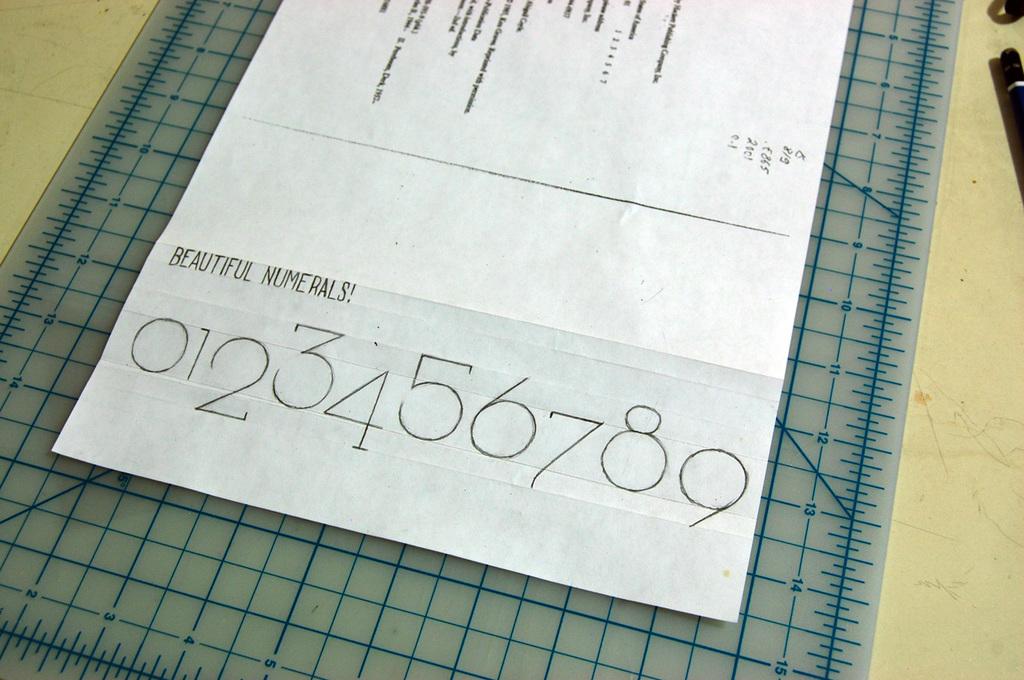What numbers are at the bottom?
Your answer should be compact. 0123456789. Is that a phone number at the bottom?
Your answer should be compact. No. 